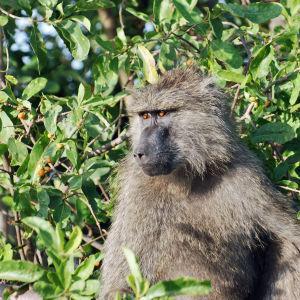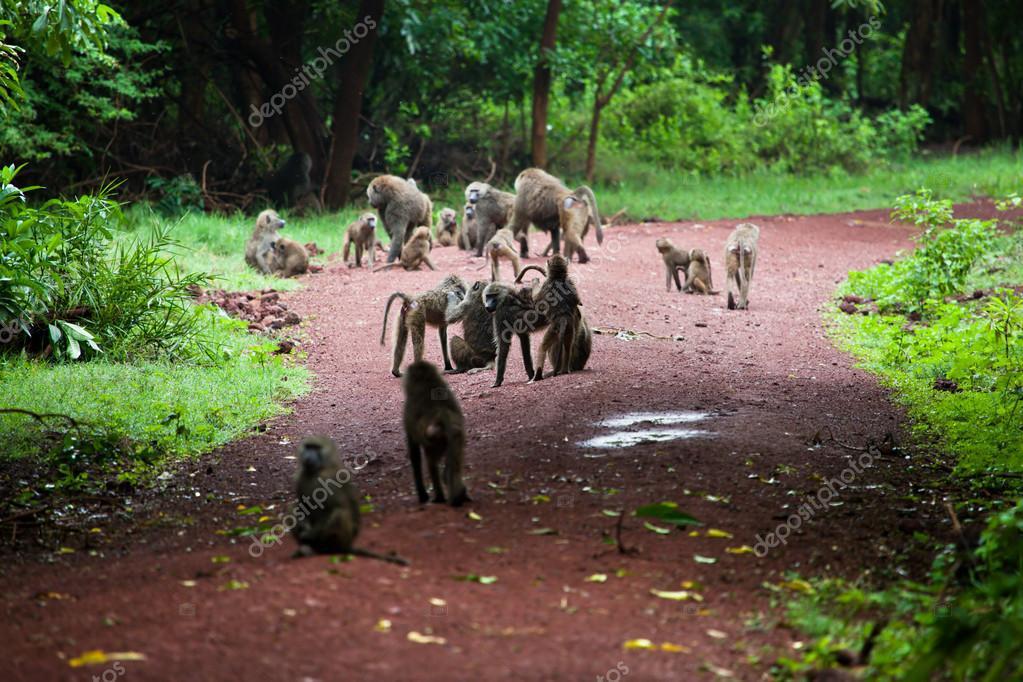The first image is the image on the left, the second image is the image on the right. Evaluate the accuracy of this statement regarding the images: "The image on the left shows a single chimp in the leaves of a tree.". Is it true? Answer yes or no. Yes. The first image is the image on the left, the second image is the image on the right. Considering the images on both sides, is "Left image shows one baboon, posed amid leafy foliage." valid? Answer yes or no. Yes. 